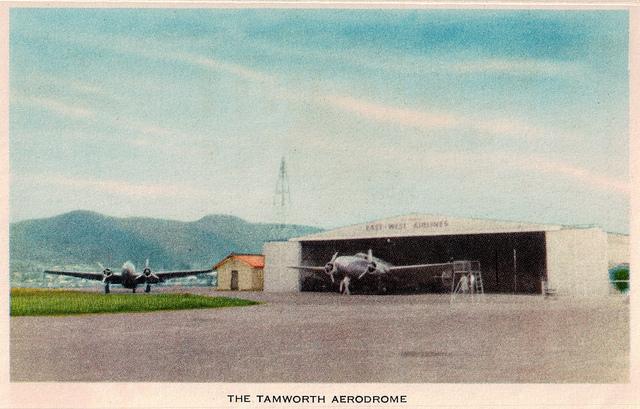Is it a black and white picture?
Answer briefly. No. How many planes?
Concise answer only. 2. What war might these planes have flown in?
Short answer required. Wwii. Is the tower made of brick?
Quick response, please. No. Who gave permission to reproduce the photograph in Figure 1?
Short answer required. Tamworth aerodrome. How many planes are shown?
Short answer required. 2. Is the plane taking off or landing?
Be succinct. Taking off. Does this plane need repairing?
Quick response, please. No. Are there any people in this picture?
Write a very short answer. Yes. What's in the background?
Answer briefly. Mountains. Is this a color photograph?
Quick response, please. Yes. Is there a kite in the sky?
Give a very brief answer. No. 